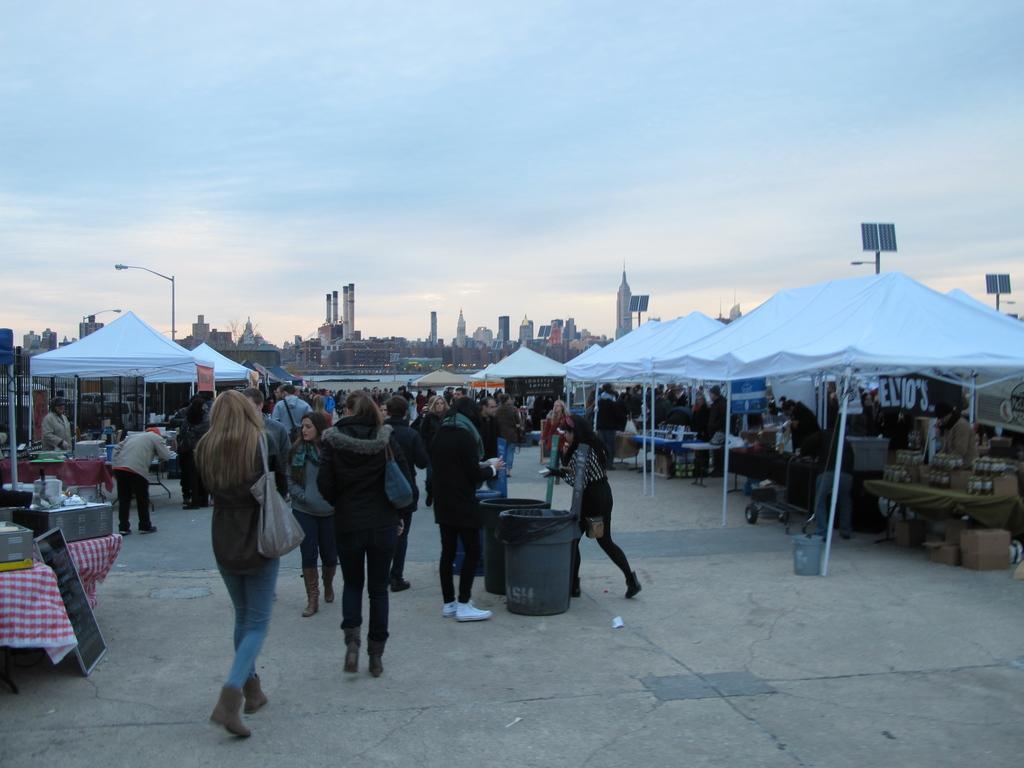Describe this image in one or two sentences. In this picture there are stalls on the right and left side of the image and there are people in the image and there are buildings and poles in the background area of the image. 